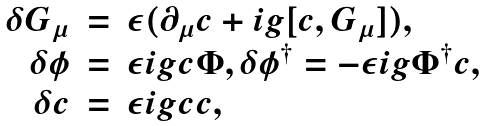<formula> <loc_0><loc_0><loc_500><loc_500>\begin{array} { r c l } \delta G _ { \mu } & = & \epsilon ( \partial _ { \mu } c + i g [ c , G _ { \mu } ] ) , \\ \delta \phi & = & \epsilon i g c \Phi , \delta \phi ^ { \dagger } = - \epsilon i g \Phi ^ { \dagger } c , \\ \delta c & = & \epsilon i g c c , \end{array}</formula> 